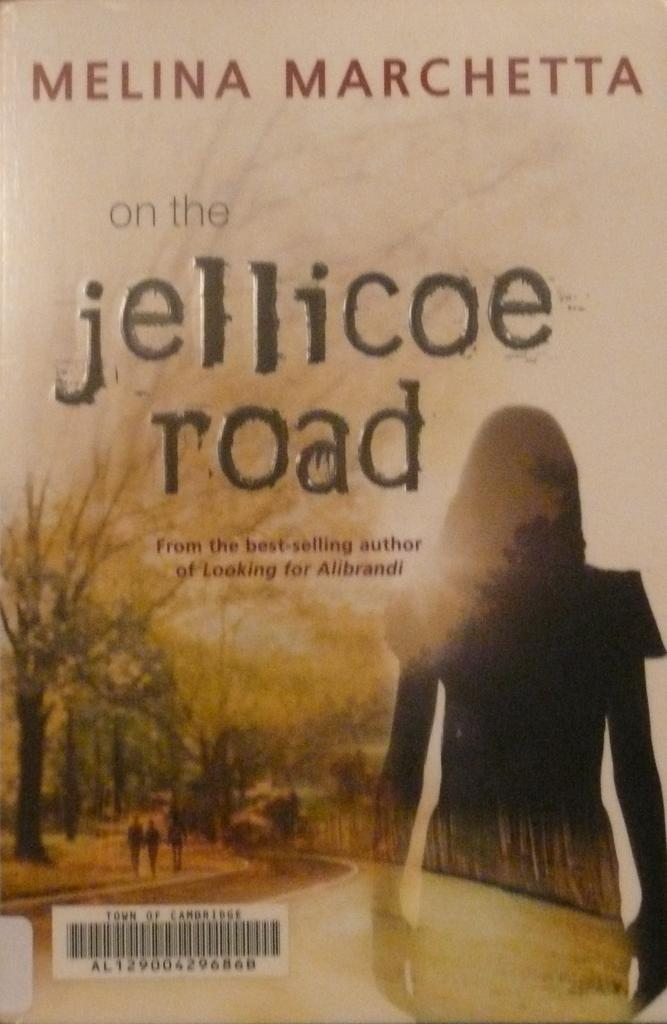<image>
Present a compact description of the photo's key features. A paperback book is written by a best selling author named Melina Marchetta. 